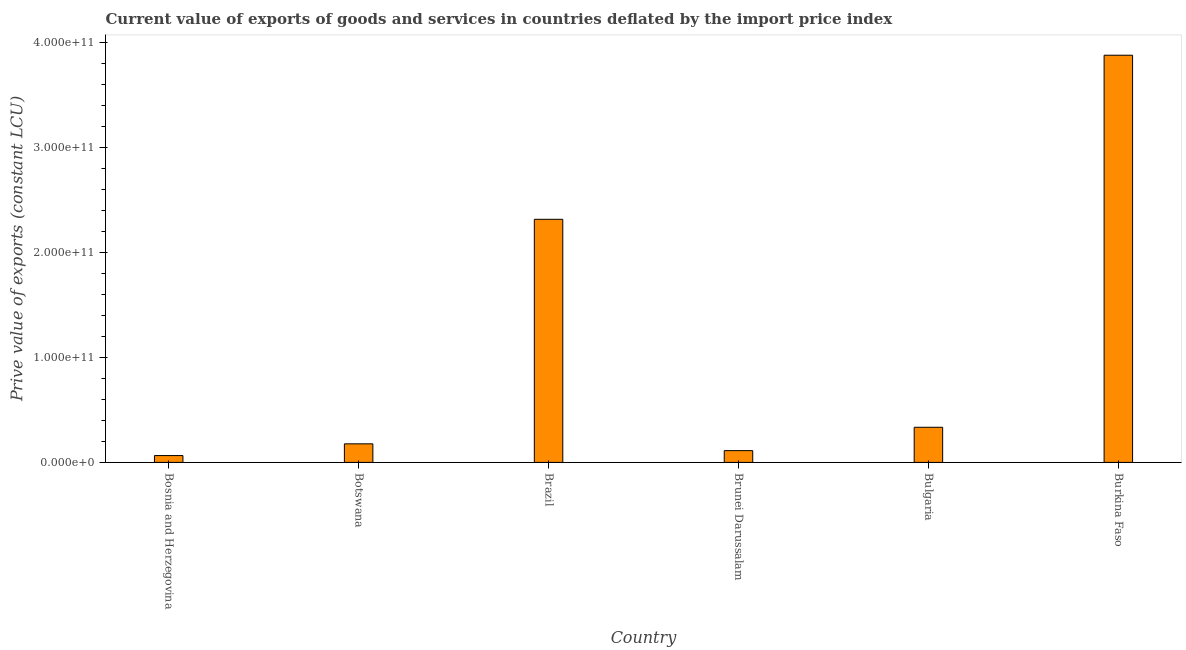Does the graph contain any zero values?
Ensure brevity in your answer.  No. Does the graph contain grids?
Offer a terse response. No. What is the title of the graph?
Your response must be concise. Current value of exports of goods and services in countries deflated by the import price index. What is the label or title of the Y-axis?
Offer a terse response. Prive value of exports (constant LCU). What is the price value of exports in Bosnia and Herzegovina?
Offer a terse response. 6.51e+09. Across all countries, what is the maximum price value of exports?
Offer a very short reply. 3.88e+11. Across all countries, what is the minimum price value of exports?
Your response must be concise. 6.51e+09. In which country was the price value of exports maximum?
Your answer should be very brief. Burkina Faso. In which country was the price value of exports minimum?
Offer a terse response. Bosnia and Herzegovina. What is the sum of the price value of exports?
Offer a very short reply. 6.89e+11. What is the difference between the price value of exports in Bosnia and Herzegovina and Burkina Faso?
Make the answer very short. -3.82e+11. What is the average price value of exports per country?
Your answer should be very brief. 1.15e+11. What is the median price value of exports?
Keep it short and to the point. 2.56e+1. What is the ratio of the price value of exports in Bosnia and Herzegovina to that in Bulgaria?
Your answer should be very brief. 0.2. Is the price value of exports in Botswana less than that in Brazil?
Ensure brevity in your answer.  Yes. What is the difference between the highest and the second highest price value of exports?
Offer a terse response. 1.56e+11. What is the difference between the highest and the lowest price value of exports?
Ensure brevity in your answer.  3.82e+11. Are all the bars in the graph horizontal?
Ensure brevity in your answer.  No. How many countries are there in the graph?
Offer a very short reply. 6. What is the difference between two consecutive major ticks on the Y-axis?
Make the answer very short. 1.00e+11. Are the values on the major ticks of Y-axis written in scientific E-notation?
Ensure brevity in your answer.  Yes. What is the Prive value of exports (constant LCU) in Bosnia and Herzegovina?
Keep it short and to the point. 6.51e+09. What is the Prive value of exports (constant LCU) of Botswana?
Provide a short and direct response. 1.77e+1. What is the Prive value of exports (constant LCU) of Brazil?
Your answer should be compact. 2.32e+11. What is the Prive value of exports (constant LCU) in Brunei Darussalam?
Your response must be concise. 1.12e+1. What is the Prive value of exports (constant LCU) in Bulgaria?
Ensure brevity in your answer.  3.35e+1. What is the Prive value of exports (constant LCU) of Burkina Faso?
Your response must be concise. 3.88e+11. What is the difference between the Prive value of exports (constant LCU) in Bosnia and Herzegovina and Botswana?
Your response must be concise. -1.12e+1. What is the difference between the Prive value of exports (constant LCU) in Bosnia and Herzegovina and Brazil?
Give a very brief answer. -2.25e+11. What is the difference between the Prive value of exports (constant LCU) in Bosnia and Herzegovina and Brunei Darussalam?
Your response must be concise. -4.70e+09. What is the difference between the Prive value of exports (constant LCU) in Bosnia and Herzegovina and Bulgaria?
Your answer should be very brief. -2.70e+1. What is the difference between the Prive value of exports (constant LCU) in Bosnia and Herzegovina and Burkina Faso?
Provide a short and direct response. -3.82e+11. What is the difference between the Prive value of exports (constant LCU) in Botswana and Brazil?
Your response must be concise. -2.14e+11. What is the difference between the Prive value of exports (constant LCU) in Botswana and Brunei Darussalam?
Your answer should be compact. 6.47e+09. What is the difference between the Prive value of exports (constant LCU) in Botswana and Bulgaria?
Your answer should be compact. -1.58e+1. What is the difference between the Prive value of exports (constant LCU) in Botswana and Burkina Faso?
Your answer should be very brief. -3.70e+11. What is the difference between the Prive value of exports (constant LCU) in Brazil and Brunei Darussalam?
Offer a very short reply. 2.21e+11. What is the difference between the Prive value of exports (constant LCU) in Brazil and Bulgaria?
Make the answer very short. 1.98e+11. What is the difference between the Prive value of exports (constant LCU) in Brazil and Burkina Faso?
Your answer should be compact. -1.56e+11. What is the difference between the Prive value of exports (constant LCU) in Brunei Darussalam and Bulgaria?
Your answer should be very brief. -2.23e+1. What is the difference between the Prive value of exports (constant LCU) in Brunei Darussalam and Burkina Faso?
Keep it short and to the point. -3.77e+11. What is the difference between the Prive value of exports (constant LCU) in Bulgaria and Burkina Faso?
Offer a terse response. -3.55e+11. What is the ratio of the Prive value of exports (constant LCU) in Bosnia and Herzegovina to that in Botswana?
Keep it short and to the point. 0.37. What is the ratio of the Prive value of exports (constant LCU) in Bosnia and Herzegovina to that in Brazil?
Give a very brief answer. 0.03. What is the ratio of the Prive value of exports (constant LCU) in Bosnia and Herzegovina to that in Brunei Darussalam?
Provide a succinct answer. 0.58. What is the ratio of the Prive value of exports (constant LCU) in Bosnia and Herzegovina to that in Bulgaria?
Your answer should be compact. 0.2. What is the ratio of the Prive value of exports (constant LCU) in Bosnia and Herzegovina to that in Burkina Faso?
Provide a short and direct response. 0.02. What is the ratio of the Prive value of exports (constant LCU) in Botswana to that in Brazil?
Offer a terse response. 0.08. What is the ratio of the Prive value of exports (constant LCU) in Botswana to that in Brunei Darussalam?
Offer a very short reply. 1.58. What is the ratio of the Prive value of exports (constant LCU) in Botswana to that in Bulgaria?
Provide a short and direct response. 0.53. What is the ratio of the Prive value of exports (constant LCU) in Botswana to that in Burkina Faso?
Keep it short and to the point. 0.05. What is the ratio of the Prive value of exports (constant LCU) in Brazil to that in Brunei Darussalam?
Make the answer very short. 20.66. What is the ratio of the Prive value of exports (constant LCU) in Brazil to that in Bulgaria?
Your answer should be very brief. 6.92. What is the ratio of the Prive value of exports (constant LCU) in Brazil to that in Burkina Faso?
Provide a succinct answer. 0.6. What is the ratio of the Prive value of exports (constant LCU) in Brunei Darussalam to that in Bulgaria?
Offer a very short reply. 0.34. What is the ratio of the Prive value of exports (constant LCU) in Brunei Darussalam to that in Burkina Faso?
Offer a terse response. 0.03. What is the ratio of the Prive value of exports (constant LCU) in Bulgaria to that in Burkina Faso?
Your answer should be very brief. 0.09. 